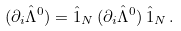<formula> <loc_0><loc_0><loc_500><loc_500>( \partial _ { i } { \hat { \Lambda } } ^ { 0 } ) = { \hat { 1 } } _ { N } \, ( \partial _ { i } { \hat { \Lambda } } ^ { 0 } ) \, { \hat { 1 } } _ { N } \, .</formula> 